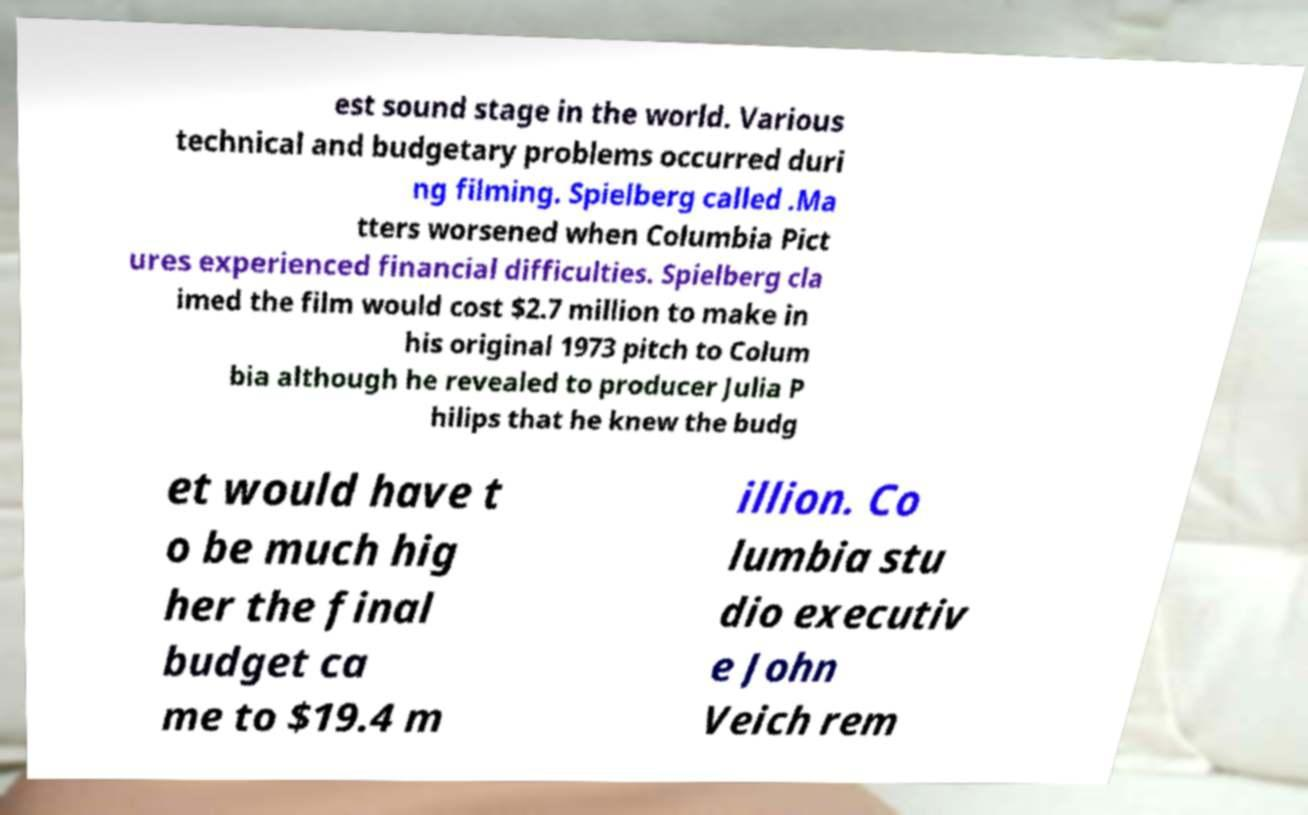Could you assist in decoding the text presented in this image and type it out clearly? est sound stage in the world. Various technical and budgetary problems occurred duri ng filming. Spielberg called .Ma tters worsened when Columbia Pict ures experienced financial difficulties. Spielberg cla imed the film would cost $2.7 million to make in his original 1973 pitch to Colum bia although he revealed to producer Julia P hilips that he knew the budg et would have t o be much hig her the final budget ca me to $19.4 m illion. Co lumbia stu dio executiv e John Veich rem 